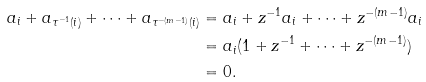Convert formula to latex. <formula><loc_0><loc_0><loc_500><loc_500>a _ { i } + a _ { \tau ^ { - 1 } ( i ) } + \cdots + a _ { \tau ^ { - ( m - 1 ) } ( i ) } & = a _ { i } + z ^ { - 1 } a _ { i } + \cdots + z ^ { - ( m - 1 ) } a _ { i } \\ & = a _ { i } ( 1 + z ^ { - 1 } + \cdots + z ^ { - ( m - 1 ) } ) \\ & = 0 .</formula> 